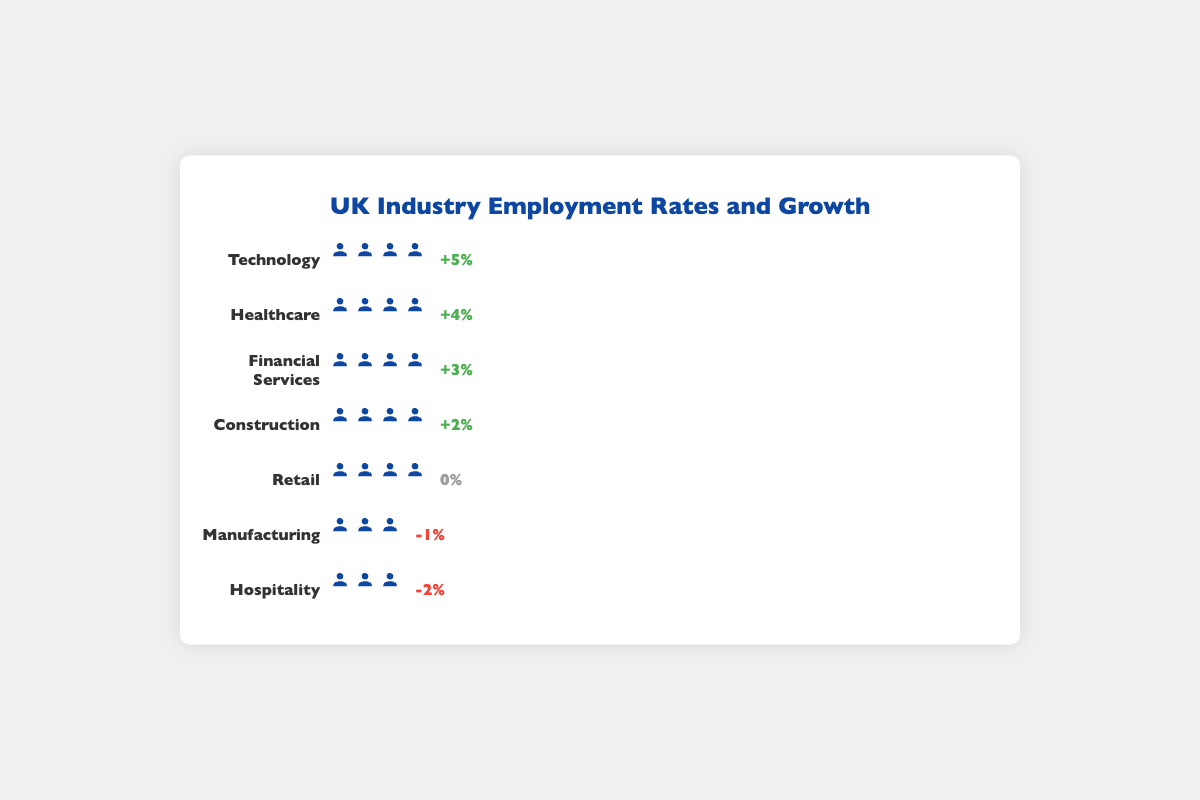What is the employment rate in the Technology industry? From the figure, locate the Technology industry row and count the number of person icons. Each icon represents a certain percentage of employment rate. Therefore, referring to the employment rate value for Technology shown in the figure is 88%.
Answer: 88% Which industry has the highest employment rate? Look at all rows and determine the industry with the most person icons representing the employment rate. The employment rate in the Technology industry is the highest at 88%.
Answer: Technology Which industries show a negative growth? Identify the industries that have a negative growth percentage displayed in red. Manufacturing has -1% and Hospitality has -2% growth.
Answer: Manufacturing, Hospitality Which industry has a growth rate of 0%? Look for the industry with a growth rate shown in gray which is neutral. The Retail industry has a 0% growth rate as indicated in the figure.
Answer: Retail How much higher is the employment rate in Healthcare compared to Hospitality? Refer to the number of person icons in the Healthcare (85%) and Hospitality (72%) rows. Subtract the employment rate of Hospitality from Healthcare: 85% - 72% = 13%.
Answer: 13% What are the employment rates for industries showing positive growth? Identify industries with green growth percentages and list their employment rates. Technology (88%), Healthcare (85%), Financial Services (82%), and Construction (81%).
Answer: Technology: 88%, Healthcare: 85%, Financial Services: 82%, Construction: 81% Which industry has the smallest positive growth rate? Among industries with green growth percentages, locate the smallest number. Construction has the smallest positive growth rate at 2%.
Answer: Construction Is the employment rate higher in Financial Services or Manufacturing? Compare the number of person icons in Financial Services (82%) and Manufacturing (76%). Financial Services has a higher employment rate.
Answer: Financial Services What is the difference in employment rates between Construction and Retail? Refer to the figure for the employment rates of Construction (81%) and Retail (79%). Subtract Retail's rate from Construction's rate: 81% - 79% = 2%.
Answer: 2% Which industry has the third-highest employment rate? Rank the employment rates and identify the third-highest. Financial Services at 82% is third after Technology and Healthcare.
Answer: Financial Services 